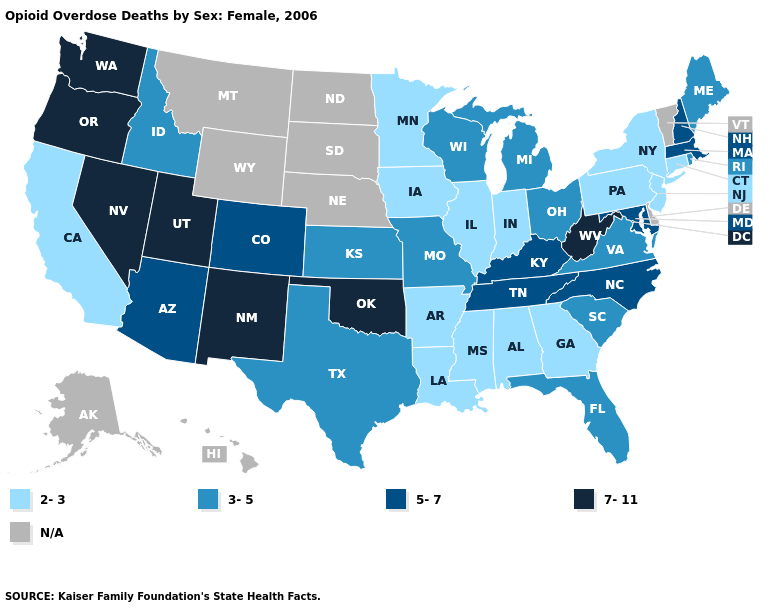Does Utah have the highest value in the West?
Answer briefly. Yes. What is the value of New Mexico?
Be succinct. 7-11. What is the lowest value in the USA?
Keep it brief. 2-3. Name the states that have a value in the range 7-11?
Short answer required. Nevada, New Mexico, Oklahoma, Oregon, Utah, Washington, West Virginia. Does Pennsylvania have the lowest value in the USA?
Quick response, please. Yes. What is the value of New Jersey?
Answer briefly. 2-3. What is the value of Alabama?
Write a very short answer. 2-3. Does Oklahoma have the highest value in the South?
Write a very short answer. Yes. Name the states that have a value in the range N/A?
Concise answer only. Alaska, Delaware, Hawaii, Montana, Nebraska, North Dakota, South Dakota, Vermont, Wyoming. What is the value of Idaho?
Concise answer only. 3-5. What is the highest value in the MidWest ?
Concise answer only. 3-5. Does Ohio have the highest value in the USA?
Write a very short answer. No. Among the states that border South Dakota , which have the lowest value?
Concise answer only. Iowa, Minnesota. Does the first symbol in the legend represent the smallest category?
Write a very short answer. Yes. 